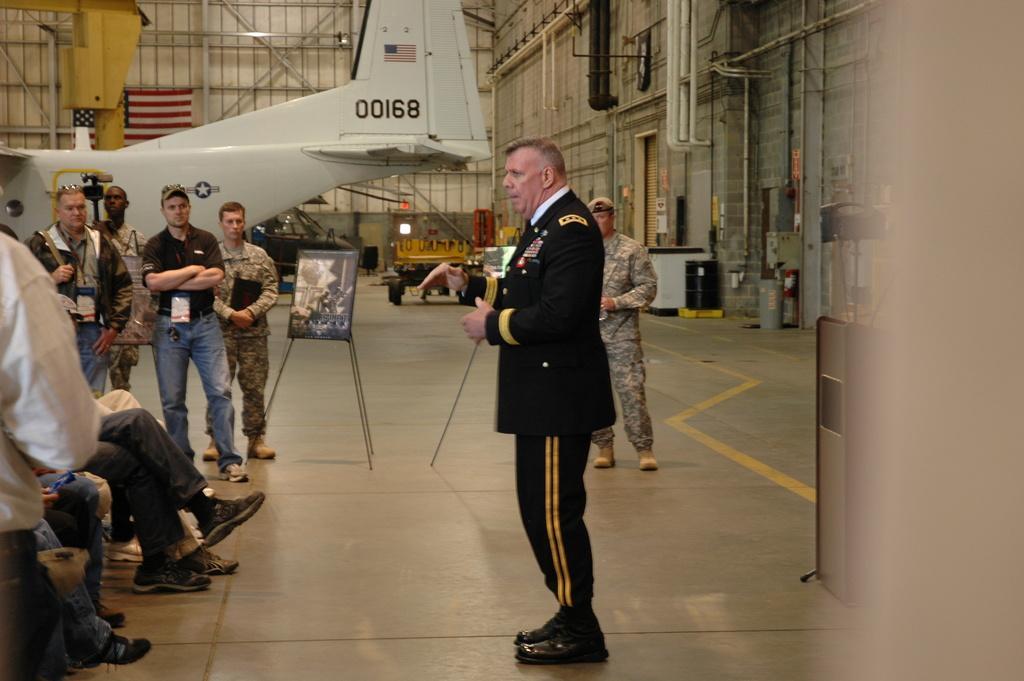Could you give a brief overview of what you see in this image? In this picture I can see the aircraft. I can see a few people sitting. I can see a few people standing on the floor. I can see stand board. I can see metal pipes. I can see the flag. 